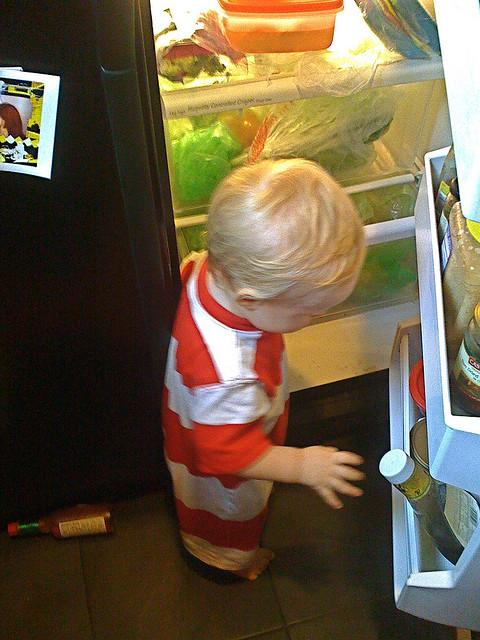What color outfit is the child wearing? Please explain your reasoning. red. The child's outfit is not blue, green, or pink. 